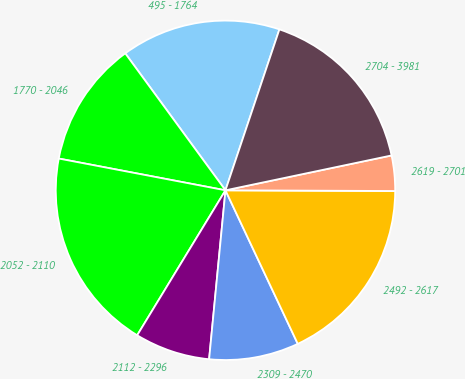Convert chart. <chart><loc_0><loc_0><loc_500><loc_500><pie_chart><fcel>495 - 1764<fcel>1770 - 2046<fcel>2052 - 2110<fcel>2112 - 2296<fcel>2309 - 2470<fcel>2492 - 2617<fcel>2619 - 2701<fcel>2704 - 3981<nl><fcel>15.2%<fcel>11.95%<fcel>19.29%<fcel>7.17%<fcel>8.54%<fcel>17.93%<fcel>3.36%<fcel>16.56%<nl></chart> 